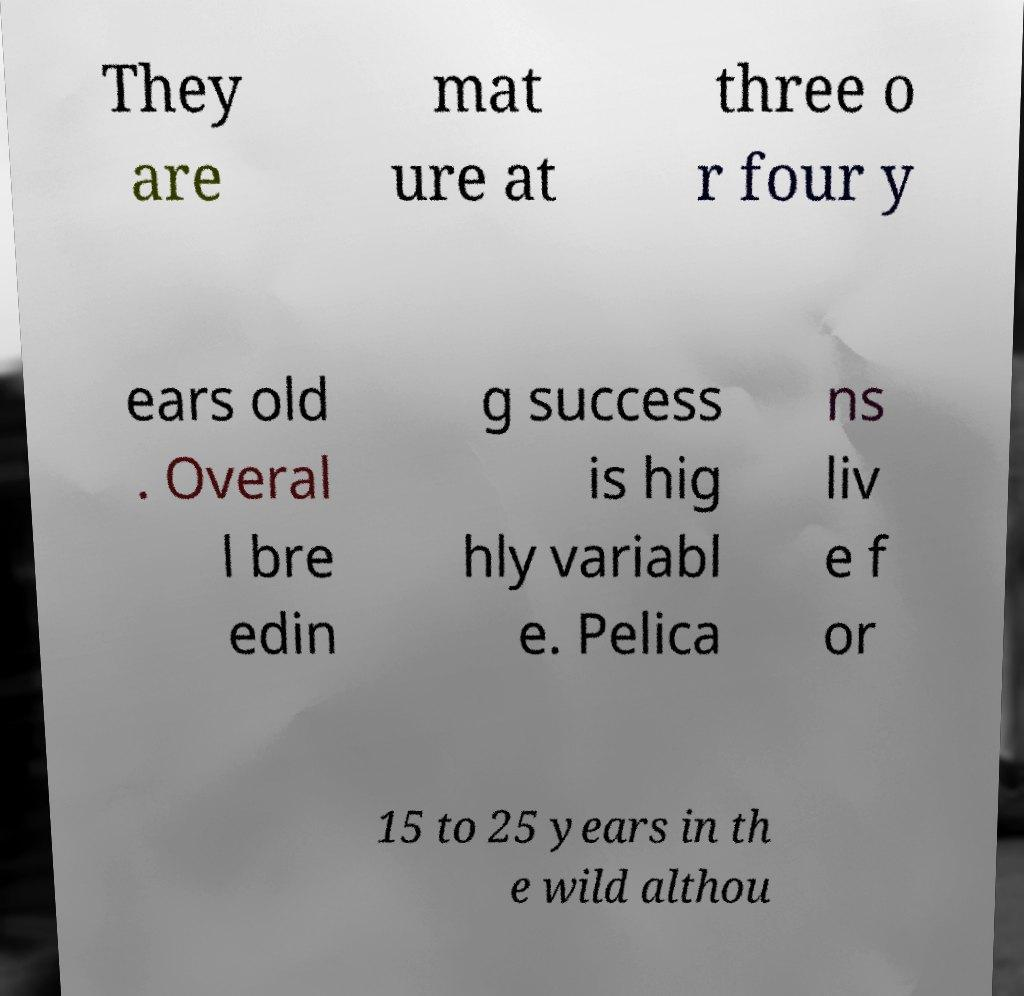Could you extract and type out the text from this image? They are mat ure at three o r four y ears old . Overal l bre edin g success is hig hly variabl e. Pelica ns liv e f or 15 to 25 years in th e wild althou 